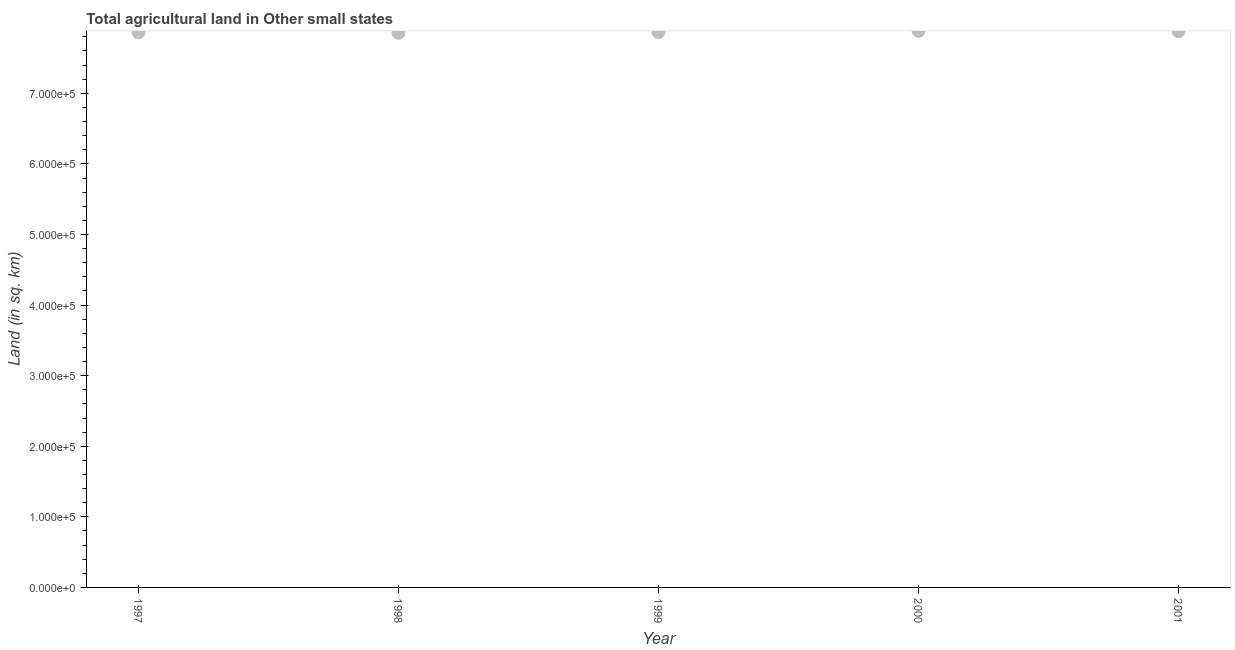What is the agricultural land in 1998?
Provide a short and direct response. 7.86e+05. Across all years, what is the maximum agricultural land?
Your response must be concise. 7.88e+05. Across all years, what is the minimum agricultural land?
Your answer should be very brief. 7.86e+05. In which year was the agricultural land maximum?
Your answer should be very brief. 2000. In which year was the agricultural land minimum?
Your response must be concise. 1998. What is the sum of the agricultural land?
Give a very brief answer. 3.93e+06. What is the difference between the agricultural land in 2000 and 2001?
Ensure brevity in your answer.  430. What is the average agricultural land per year?
Offer a very short reply. 7.87e+05. What is the median agricultural land?
Give a very brief answer. 7.87e+05. In how many years, is the agricultural land greater than 220000 sq. km?
Give a very brief answer. 5. What is the ratio of the agricultural land in 2000 to that in 2001?
Provide a short and direct response. 1. Is the difference between the agricultural land in 1998 and 1999 greater than the difference between any two years?
Your answer should be compact. No. What is the difference between the highest and the second highest agricultural land?
Ensure brevity in your answer.  430. What is the difference between the highest and the lowest agricultural land?
Offer a terse response. 2750. In how many years, is the agricultural land greater than the average agricultural land taken over all years?
Ensure brevity in your answer.  2. Does the agricultural land monotonically increase over the years?
Make the answer very short. No. What is the difference between two consecutive major ticks on the Y-axis?
Give a very brief answer. 1.00e+05. Does the graph contain any zero values?
Your answer should be very brief. No. Does the graph contain grids?
Your response must be concise. No. What is the title of the graph?
Provide a short and direct response. Total agricultural land in Other small states. What is the label or title of the X-axis?
Ensure brevity in your answer.  Year. What is the label or title of the Y-axis?
Your answer should be compact. Land (in sq. km). What is the Land (in sq. km) in 1997?
Your answer should be compact. 7.86e+05. What is the Land (in sq. km) in 1998?
Provide a succinct answer. 7.86e+05. What is the Land (in sq. km) in 1999?
Give a very brief answer. 7.87e+05. What is the Land (in sq. km) in 2000?
Provide a succinct answer. 7.88e+05. What is the Land (in sq. km) in 2001?
Your answer should be very brief. 7.88e+05. What is the difference between the Land (in sq. km) in 1997 and 1998?
Provide a short and direct response. 730. What is the difference between the Land (in sq. km) in 1997 and 1999?
Provide a short and direct response. -340. What is the difference between the Land (in sq. km) in 1997 and 2000?
Your answer should be compact. -2020. What is the difference between the Land (in sq. km) in 1997 and 2001?
Your answer should be very brief. -1590. What is the difference between the Land (in sq. km) in 1998 and 1999?
Offer a terse response. -1070. What is the difference between the Land (in sq. km) in 1998 and 2000?
Offer a terse response. -2750. What is the difference between the Land (in sq. km) in 1998 and 2001?
Your answer should be compact. -2320. What is the difference between the Land (in sq. km) in 1999 and 2000?
Give a very brief answer. -1680. What is the difference between the Land (in sq. km) in 1999 and 2001?
Provide a short and direct response. -1250. What is the difference between the Land (in sq. km) in 2000 and 2001?
Your response must be concise. 430. What is the ratio of the Land (in sq. km) in 1997 to that in 1999?
Your answer should be very brief. 1. What is the ratio of the Land (in sq. km) in 1998 to that in 2000?
Provide a short and direct response. 1. What is the ratio of the Land (in sq. km) in 1998 to that in 2001?
Ensure brevity in your answer.  1. What is the ratio of the Land (in sq. km) in 1999 to that in 2001?
Your answer should be very brief. 1. 